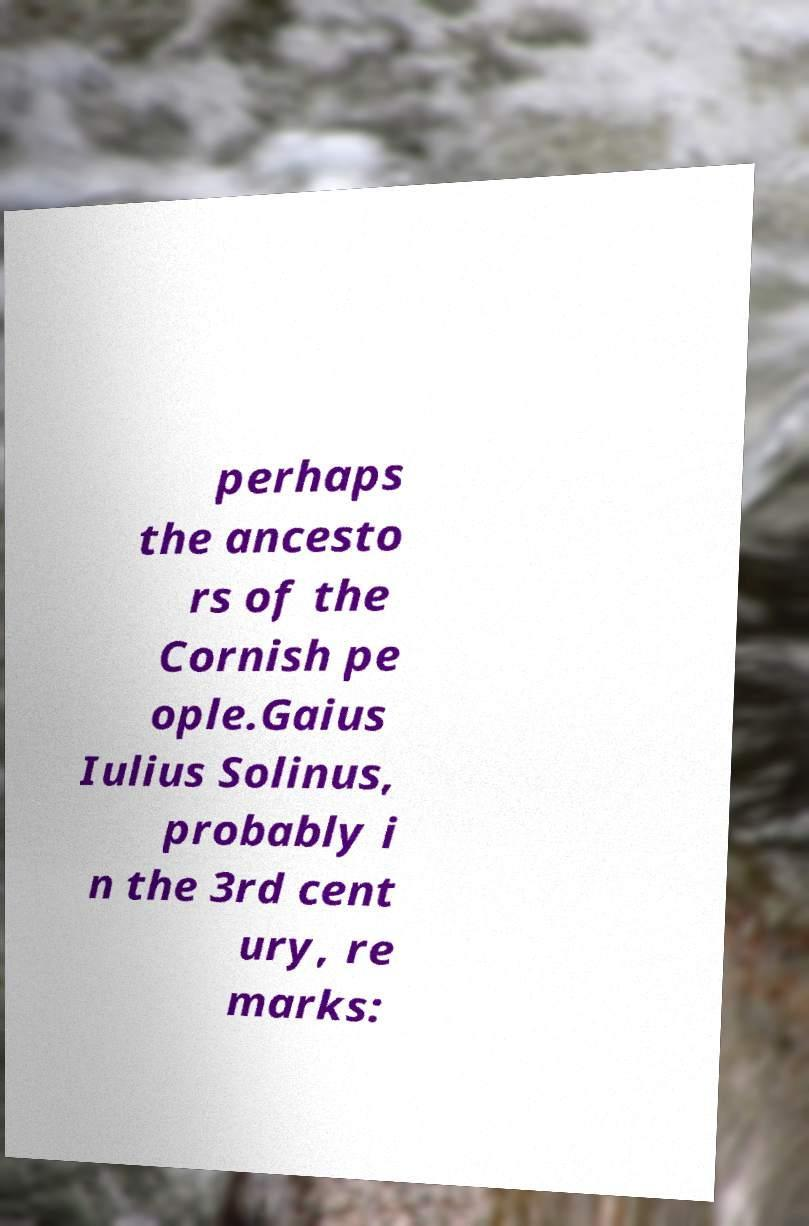Please identify and transcribe the text found in this image. perhaps the ancesto rs of the Cornish pe ople.Gaius Iulius Solinus, probably i n the 3rd cent ury, re marks: 